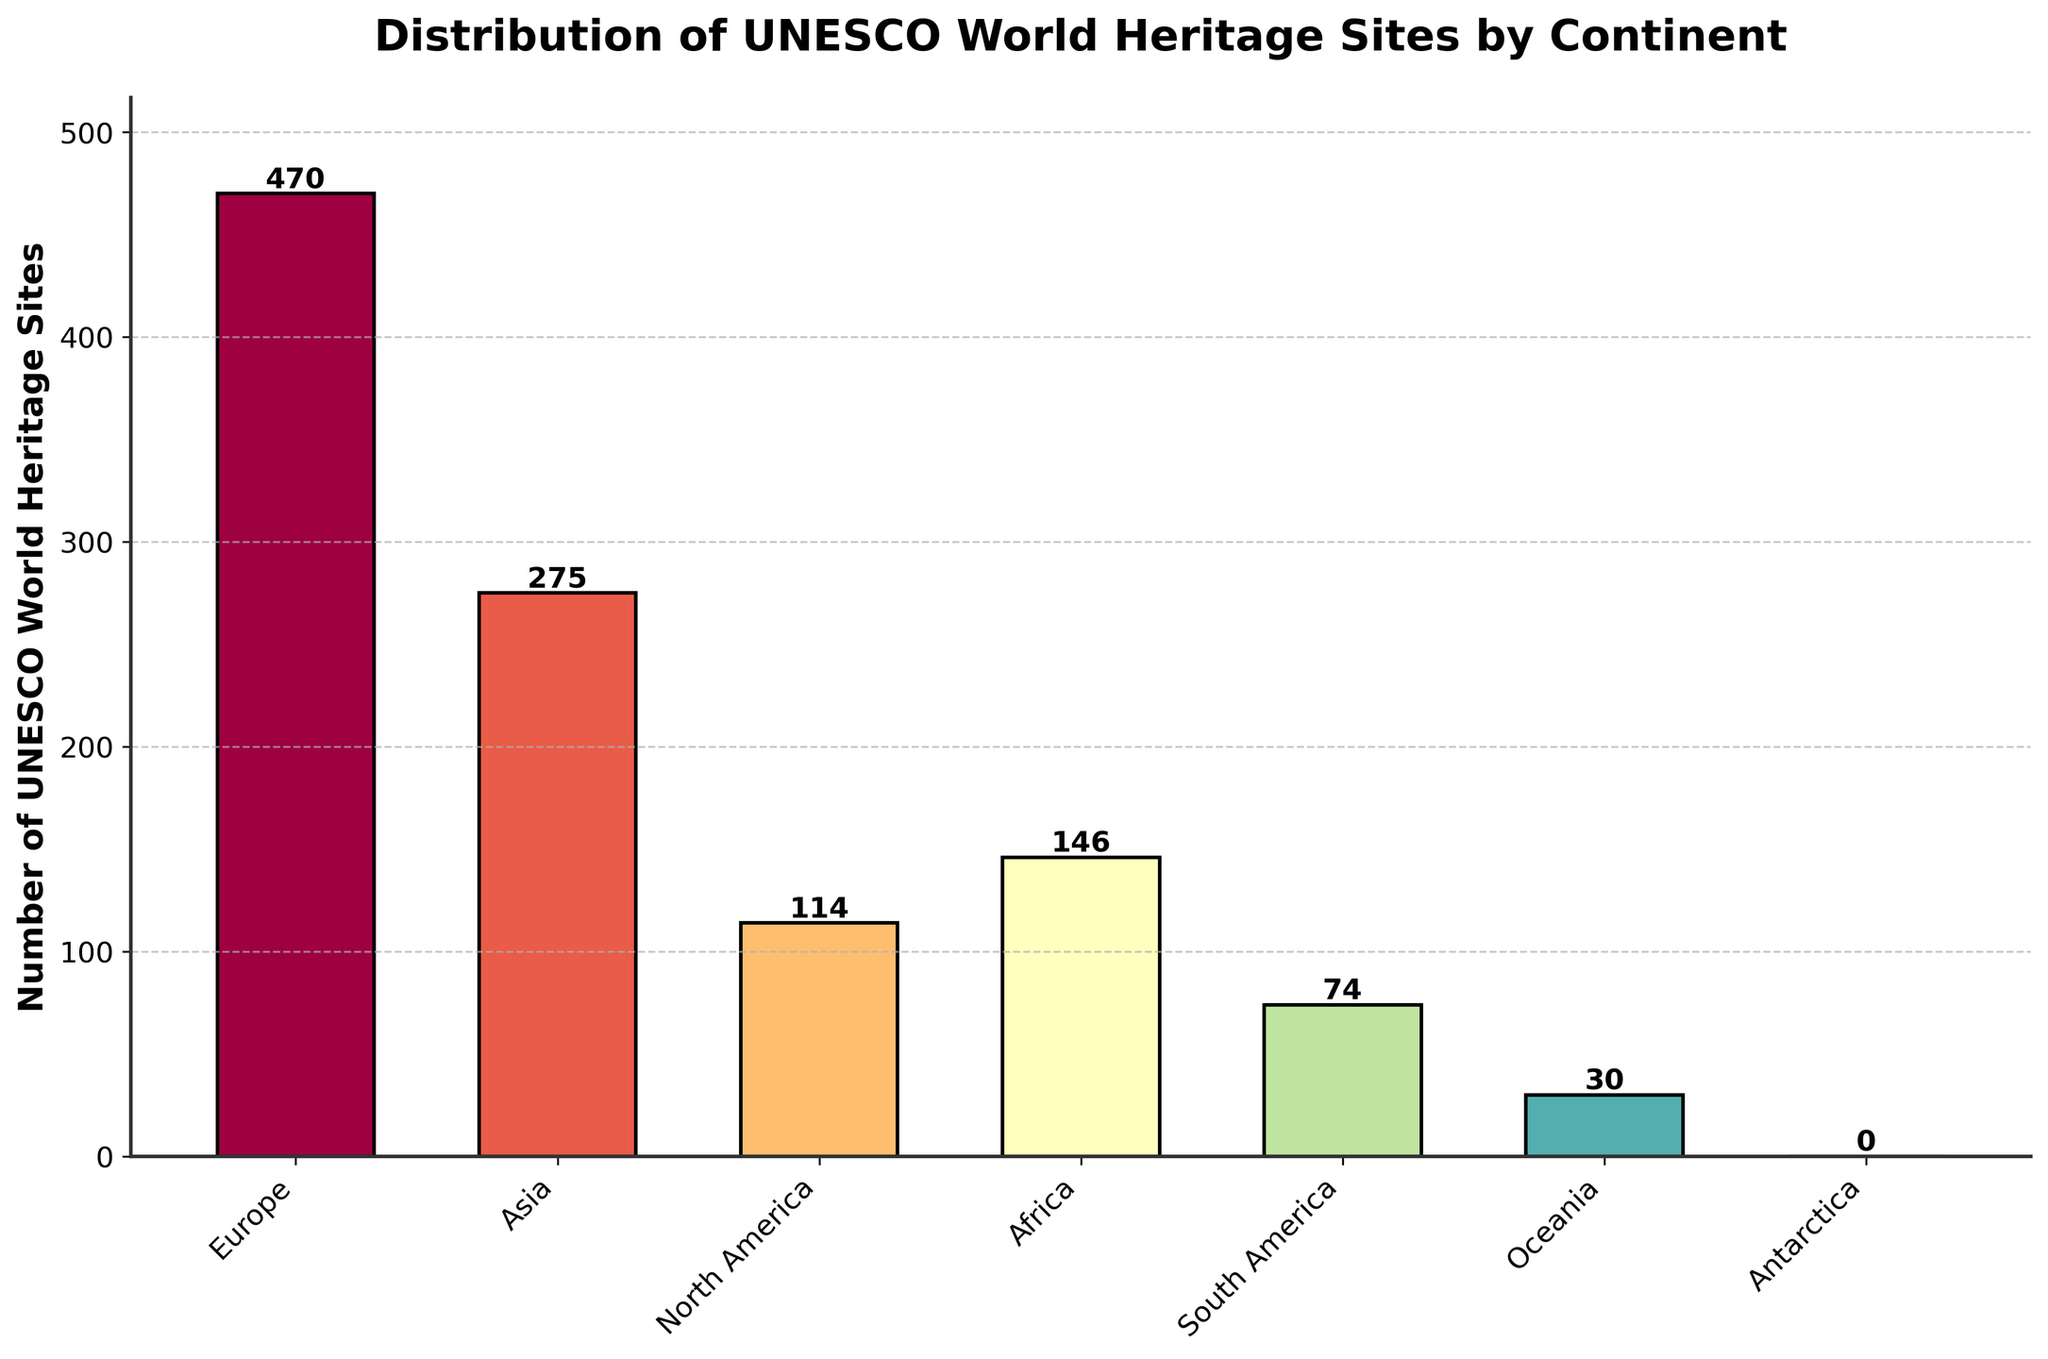Which continent has the highest number of UNESCO World Heritage Sites? Europe has the highest World Heritage Sites as its bar is the tallest in the figure.
Answer: Europe What is the total number of World Heritage Sites in Africa and South America? Add the number of sites in Africa (146) and South America (74): 146 + 74 = 220.
Answer: 220 Which two continents have the lowest number of UNESCO World Heritage Sites? Oceania and Antarctica have the lowest, as indicated by their bars being the shortest and nonexistent, respectively.
Answer: Oceania and Antarctica How many more sites does Europe have than Asia? Subtract the number of sites in Asia (275) from Europe (470): 470 - 275 = 195.
Answer: 195 Which continent has almost double the number of sites compared to North America? Europe's bar is more than 400 and nearly double North America's bar: 470 is approximately double 114.
Answer: Europe Which continent has no UNESCO World Heritage Sites? Look for the bar with a height of 0; it corresponds to Antarctica.
Answer: Antarctica Estimate how much higher the bar for Europe is compared to the one for Africa in terms of visual height. Calculate by comparing the data: Europe's number (470) - Africa's number (146): 470 - 146 = 324. Europe's bar is visually significantly taller.
Answer: 324 How many continents have over 100 UNESCO World Heritage Sites? Count bars representing over 100 sites: Europe, Asia, North America, Africa.
Answer: Four Which continent's bar is closest in height to Asia's? North America's bar is closest, as the next highest after Asia, although it's still a significant difference.
Answer: North America What is the combined total number of World Heritage Sites in continents with fewer than 100 sites each? Add the number of sites in South America (74) and Oceania (30): 74 + 30 = 104.
Answer: 104 